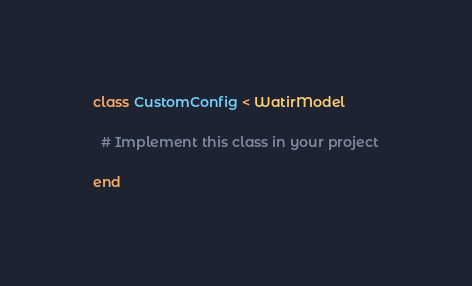<code> <loc_0><loc_0><loc_500><loc_500><_Ruby_>class CustomConfig < WatirModel

  # Implement this class in your project

end
</code> 